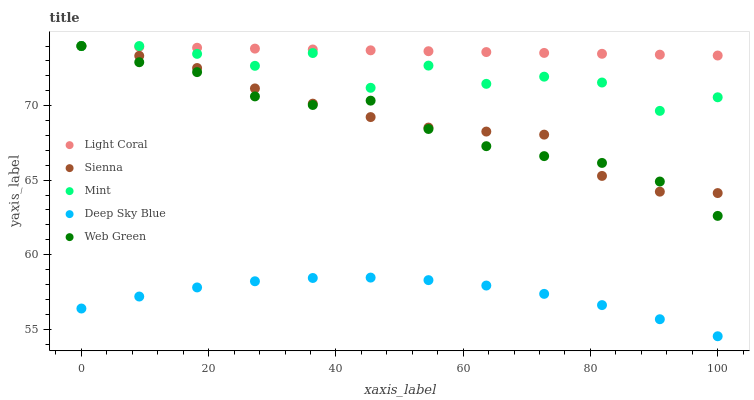Does Deep Sky Blue have the minimum area under the curve?
Answer yes or no. Yes. Does Light Coral have the maximum area under the curve?
Answer yes or no. Yes. Does Sienna have the minimum area under the curve?
Answer yes or no. No. Does Sienna have the maximum area under the curve?
Answer yes or no. No. Is Light Coral the smoothest?
Answer yes or no. Yes. Is Mint the roughest?
Answer yes or no. Yes. Is Sienna the smoothest?
Answer yes or no. No. Is Sienna the roughest?
Answer yes or no. No. Does Deep Sky Blue have the lowest value?
Answer yes or no. Yes. Does Sienna have the lowest value?
Answer yes or no. No. Does Web Green have the highest value?
Answer yes or no. Yes. Does Deep Sky Blue have the highest value?
Answer yes or no. No. Is Deep Sky Blue less than Web Green?
Answer yes or no. Yes. Is Light Coral greater than Deep Sky Blue?
Answer yes or no. Yes. Does Sienna intersect Light Coral?
Answer yes or no. Yes. Is Sienna less than Light Coral?
Answer yes or no. No. Is Sienna greater than Light Coral?
Answer yes or no. No. Does Deep Sky Blue intersect Web Green?
Answer yes or no. No. 